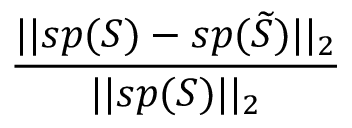Convert formula to latex. <formula><loc_0><loc_0><loc_500><loc_500>\frac { | | s p ( S ) - s p ( \widetilde { S } ) | | _ { 2 } } { | | s p ( S ) | | _ { 2 } }</formula> 